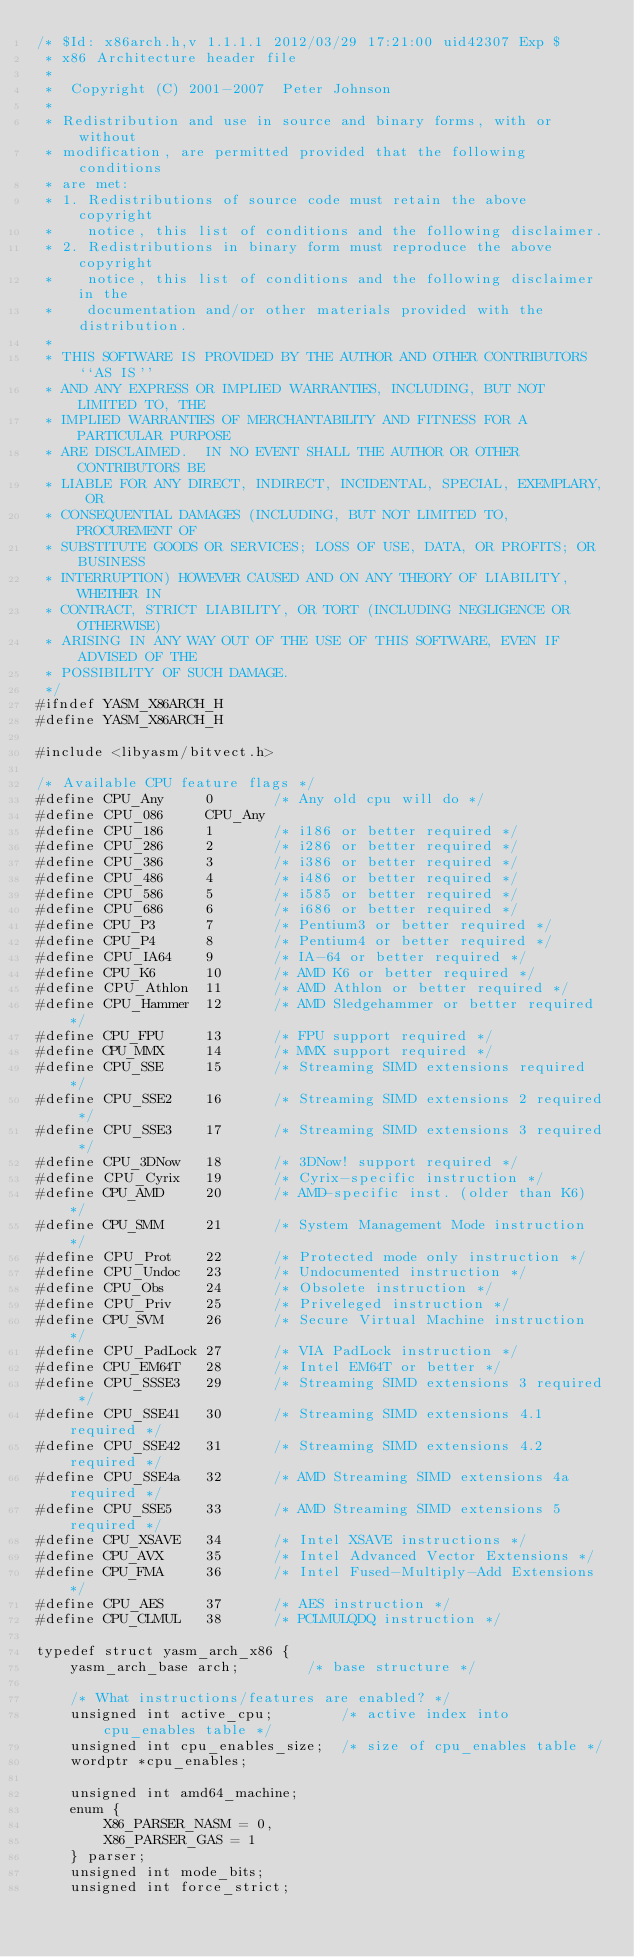<code> <loc_0><loc_0><loc_500><loc_500><_C_>/* $Id: x86arch.h,v 1.1.1.1 2012/03/29 17:21:00 uid42307 Exp $
 * x86 Architecture header file
 *
 *  Copyright (C) 2001-2007  Peter Johnson
 *
 * Redistribution and use in source and binary forms, with or without
 * modification, are permitted provided that the following conditions
 * are met:
 * 1. Redistributions of source code must retain the above copyright
 *    notice, this list of conditions and the following disclaimer.
 * 2. Redistributions in binary form must reproduce the above copyright
 *    notice, this list of conditions and the following disclaimer in the
 *    documentation and/or other materials provided with the distribution.
 *
 * THIS SOFTWARE IS PROVIDED BY THE AUTHOR AND OTHER CONTRIBUTORS ``AS IS''
 * AND ANY EXPRESS OR IMPLIED WARRANTIES, INCLUDING, BUT NOT LIMITED TO, THE
 * IMPLIED WARRANTIES OF MERCHANTABILITY AND FITNESS FOR A PARTICULAR PURPOSE
 * ARE DISCLAIMED.  IN NO EVENT SHALL THE AUTHOR OR OTHER CONTRIBUTORS BE
 * LIABLE FOR ANY DIRECT, INDIRECT, INCIDENTAL, SPECIAL, EXEMPLARY, OR
 * CONSEQUENTIAL DAMAGES (INCLUDING, BUT NOT LIMITED TO, PROCUREMENT OF
 * SUBSTITUTE GOODS OR SERVICES; LOSS OF USE, DATA, OR PROFITS; OR BUSINESS
 * INTERRUPTION) HOWEVER CAUSED AND ON ANY THEORY OF LIABILITY, WHETHER IN
 * CONTRACT, STRICT LIABILITY, OR TORT (INCLUDING NEGLIGENCE OR OTHERWISE)
 * ARISING IN ANY WAY OUT OF THE USE OF THIS SOFTWARE, EVEN IF ADVISED OF THE
 * POSSIBILITY OF SUCH DAMAGE.
 */
#ifndef YASM_X86ARCH_H
#define YASM_X86ARCH_H

#include <libyasm/bitvect.h>

/* Available CPU feature flags */
#define CPU_Any     0       /* Any old cpu will do */
#define CPU_086     CPU_Any
#define CPU_186     1       /* i186 or better required */
#define CPU_286     2       /* i286 or better required */
#define CPU_386     3       /* i386 or better required */
#define CPU_486     4       /* i486 or better required */
#define CPU_586     5       /* i585 or better required */
#define CPU_686     6       /* i686 or better required */
#define CPU_P3      7       /* Pentium3 or better required */
#define CPU_P4      8       /* Pentium4 or better required */
#define CPU_IA64    9       /* IA-64 or better required */
#define CPU_K6      10      /* AMD K6 or better required */
#define CPU_Athlon  11      /* AMD Athlon or better required */
#define CPU_Hammer  12      /* AMD Sledgehammer or better required */
#define CPU_FPU     13      /* FPU support required */
#define CPU_MMX     14      /* MMX support required */
#define CPU_SSE     15      /* Streaming SIMD extensions required */
#define CPU_SSE2    16      /* Streaming SIMD extensions 2 required */
#define CPU_SSE3    17      /* Streaming SIMD extensions 3 required */
#define CPU_3DNow   18      /* 3DNow! support required */
#define CPU_Cyrix   19      /* Cyrix-specific instruction */
#define CPU_AMD     20      /* AMD-specific inst. (older than K6) */
#define CPU_SMM     21      /* System Management Mode instruction */
#define CPU_Prot    22      /* Protected mode only instruction */
#define CPU_Undoc   23      /* Undocumented instruction */
#define CPU_Obs     24      /* Obsolete instruction */
#define CPU_Priv    25      /* Priveleged instruction */
#define CPU_SVM     26      /* Secure Virtual Machine instruction */
#define CPU_PadLock 27      /* VIA PadLock instruction */
#define CPU_EM64T   28      /* Intel EM64T or better */
#define CPU_SSSE3   29      /* Streaming SIMD extensions 3 required */
#define CPU_SSE41   30      /* Streaming SIMD extensions 4.1 required */
#define CPU_SSE42   31      /* Streaming SIMD extensions 4.2 required */
#define CPU_SSE4a   32      /* AMD Streaming SIMD extensions 4a required */
#define CPU_SSE5    33      /* AMD Streaming SIMD extensions 5 required */
#define CPU_XSAVE   34      /* Intel XSAVE instructions */
#define CPU_AVX     35      /* Intel Advanced Vector Extensions */
#define CPU_FMA     36      /* Intel Fused-Multiply-Add Extensions */
#define CPU_AES     37      /* AES instruction */
#define CPU_CLMUL   38      /* PCLMULQDQ instruction */

typedef struct yasm_arch_x86 {
    yasm_arch_base arch;        /* base structure */

    /* What instructions/features are enabled? */
    unsigned int active_cpu;        /* active index into cpu_enables table */
    unsigned int cpu_enables_size;  /* size of cpu_enables table */
    wordptr *cpu_enables;

    unsigned int amd64_machine;
    enum {
        X86_PARSER_NASM = 0,
        X86_PARSER_GAS = 1
    } parser;
    unsigned int mode_bits;
    unsigned int force_strict;</code> 